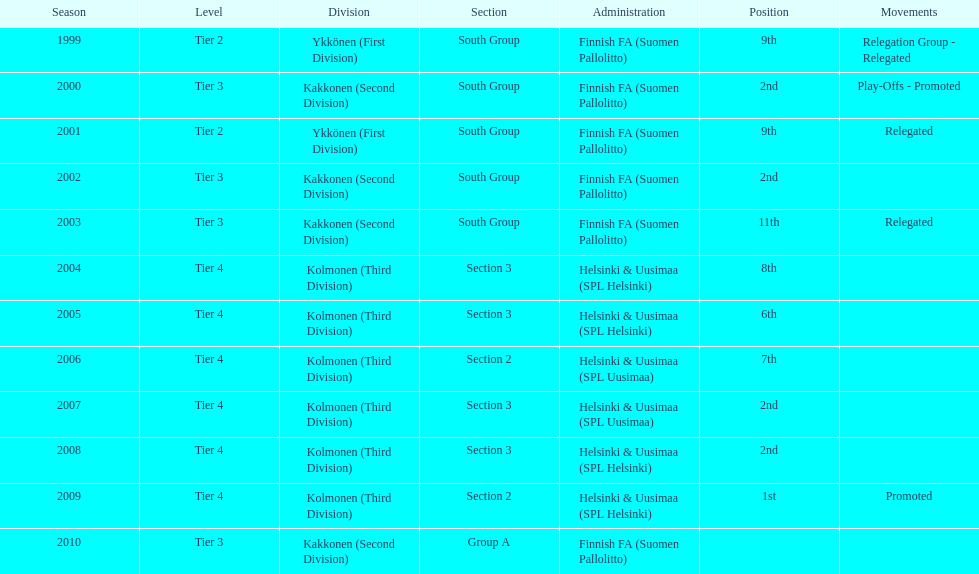Which was the only kolmonen whose movements were promoted? 2009. Would you be able to parse every entry in this table? {'header': ['Season', 'Level', 'Division', 'Section', 'Administration', 'Position', 'Movements'], 'rows': [['1999', 'Tier 2', 'Ykkönen (First Division)', 'South Group', 'Finnish FA (Suomen Pallolitto)', '9th', 'Relegation Group - Relegated'], ['2000', 'Tier 3', 'Kakkonen (Second Division)', 'South Group', 'Finnish FA (Suomen Pallolitto)', '2nd', 'Play-Offs - Promoted'], ['2001', 'Tier 2', 'Ykkönen (First Division)', 'South Group', 'Finnish FA (Suomen Pallolitto)', '9th', 'Relegated'], ['2002', 'Tier 3', 'Kakkonen (Second Division)', 'South Group', 'Finnish FA (Suomen Pallolitto)', '2nd', ''], ['2003', 'Tier 3', 'Kakkonen (Second Division)', 'South Group', 'Finnish FA (Suomen Pallolitto)', '11th', 'Relegated'], ['2004', 'Tier 4', 'Kolmonen (Third Division)', 'Section 3', 'Helsinki & Uusimaa (SPL Helsinki)', '8th', ''], ['2005', 'Tier 4', 'Kolmonen (Third Division)', 'Section 3', 'Helsinki & Uusimaa (SPL Helsinki)', '6th', ''], ['2006', 'Tier 4', 'Kolmonen (Third Division)', 'Section 2', 'Helsinki & Uusimaa (SPL Uusimaa)', '7th', ''], ['2007', 'Tier 4', 'Kolmonen (Third Division)', 'Section 3', 'Helsinki & Uusimaa (SPL Uusimaa)', '2nd', ''], ['2008', 'Tier 4', 'Kolmonen (Third Division)', 'Section 3', 'Helsinki & Uusimaa (SPL Helsinki)', '2nd', ''], ['2009', 'Tier 4', 'Kolmonen (Third Division)', 'Section 2', 'Helsinki & Uusimaa (SPL Helsinki)', '1st', 'Promoted'], ['2010', 'Tier 3', 'Kakkonen (Second Division)', 'Group A', 'Finnish FA (Suomen Pallolitto)', '', '']]} 